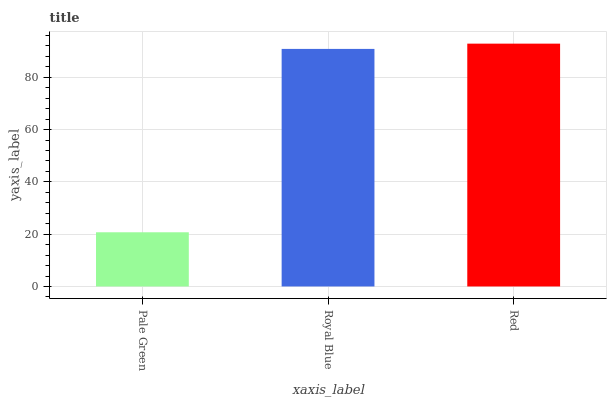Is Pale Green the minimum?
Answer yes or no. Yes. Is Red the maximum?
Answer yes or no. Yes. Is Royal Blue the minimum?
Answer yes or no. No. Is Royal Blue the maximum?
Answer yes or no. No. Is Royal Blue greater than Pale Green?
Answer yes or no. Yes. Is Pale Green less than Royal Blue?
Answer yes or no. Yes. Is Pale Green greater than Royal Blue?
Answer yes or no. No. Is Royal Blue less than Pale Green?
Answer yes or no. No. Is Royal Blue the high median?
Answer yes or no. Yes. Is Royal Blue the low median?
Answer yes or no. Yes. Is Pale Green the high median?
Answer yes or no. No. Is Red the low median?
Answer yes or no. No. 